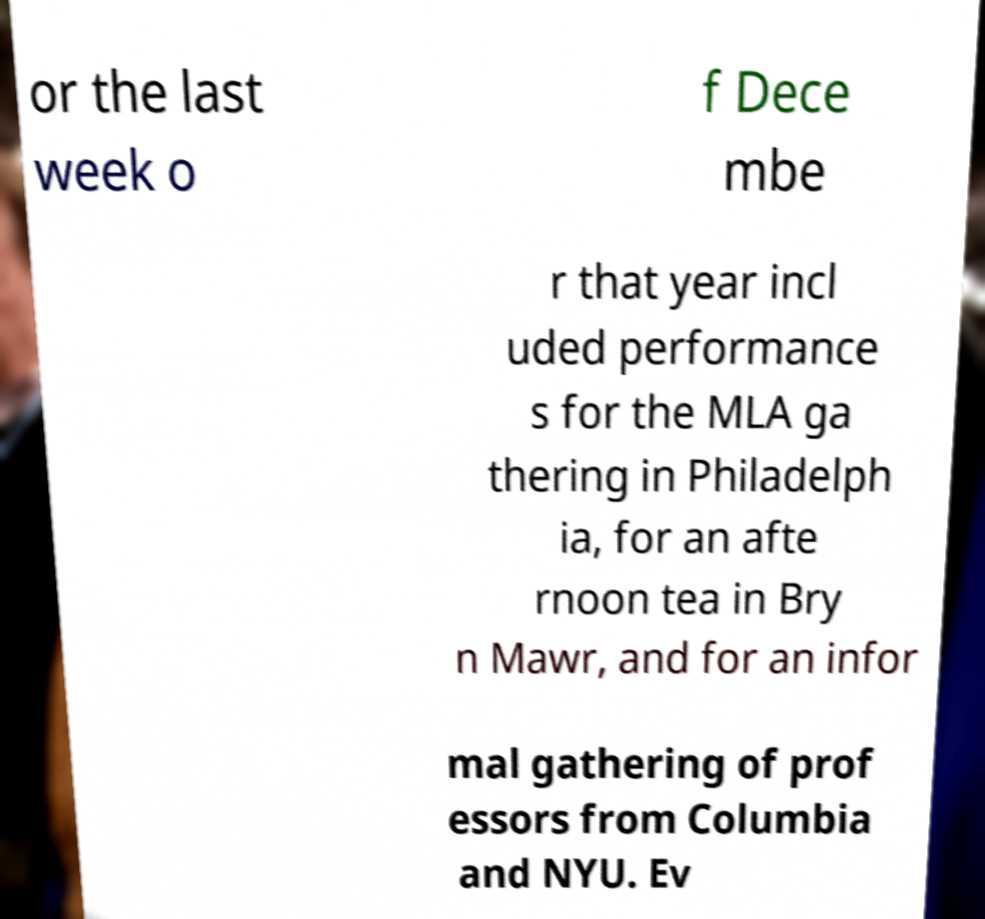I need the written content from this picture converted into text. Can you do that? or the last week o f Dece mbe r that year incl uded performance s for the MLA ga thering in Philadelph ia, for an afte rnoon tea in Bry n Mawr, and for an infor mal gathering of prof essors from Columbia and NYU. Ev 